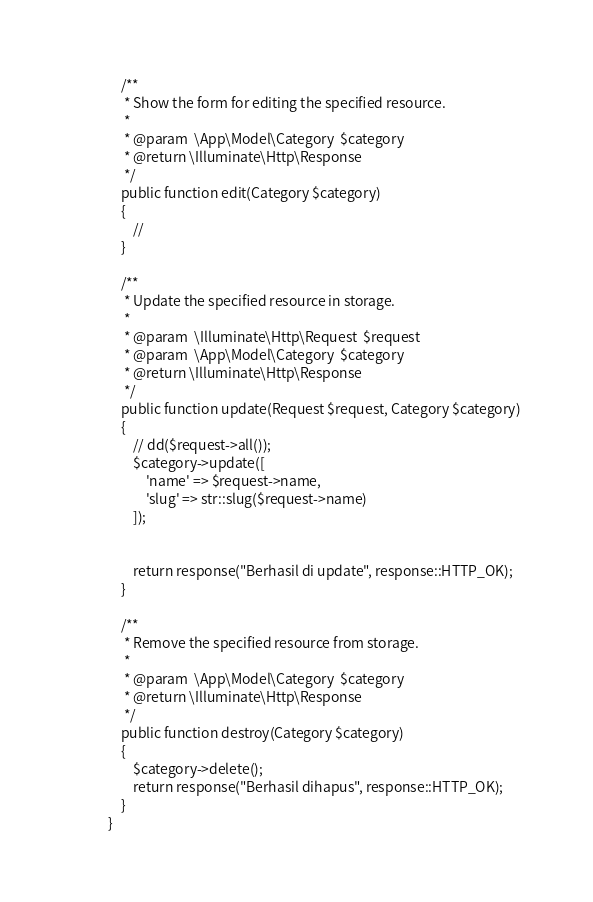Convert code to text. <code><loc_0><loc_0><loc_500><loc_500><_PHP_>    /**
     * Show the form for editing the specified resource.
     *
     * @param  \App\Model\Category  $category
     * @return \Illuminate\Http\Response
     */
    public function edit(Category $category)
    {
        //
    }

    /**
     * Update the specified resource in storage.
     *
     * @param  \Illuminate\Http\Request  $request
     * @param  \App\Model\Category  $category
     * @return \Illuminate\Http\Response
     */
    public function update(Request $request, Category $category)
    {
        // dd($request->all());
        $category->update([
            'name' => $request->name,
            'slug' => str::slug($request->name)
        ]);
        

        return response("Berhasil di update", response::HTTP_OK);
    }

    /**
     * Remove the specified resource from storage.
     *
     * @param  \App\Model\Category  $category
     * @return \Illuminate\Http\Response
     */
    public function destroy(Category $category)
    {
        $category->delete();
        return response("Berhasil dihapus", response::HTTP_OK);
    }
}</code> 